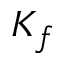<formula> <loc_0><loc_0><loc_500><loc_500>K _ { f }</formula> 